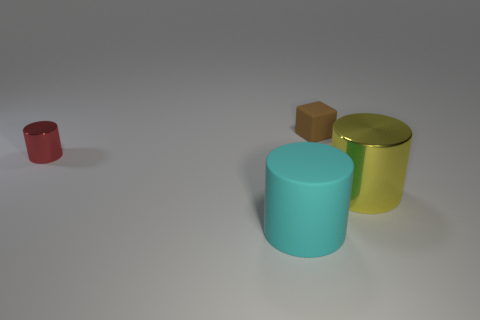Add 2 tiny red matte things. How many objects exist? 6 Subtract all cylinders. How many objects are left? 1 Subtract all large matte things. Subtract all tiny red metal things. How many objects are left? 2 Add 2 cyan matte cylinders. How many cyan matte cylinders are left? 3 Add 2 large rubber things. How many large rubber things exist? 3 Subtract all matte cylinders. How many cylinders are left? 2 Subtract 0 cyan cubes. How many objects are left? 4 Subtract 3 cylinders. How many cylinders are left? 0 Subtract all gray cubes. Subtract all blue balls. How many cubes are left? 1 Subtract all brown cylinders. How many cyan blocks are left? 0 